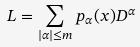<formula> <loc_0><loc_0><loc_500><loc_500>L = \sum _ { | \alpha | \leq m } p _ { \alpha } ( x ) D ^ { \alpha }</formula> 